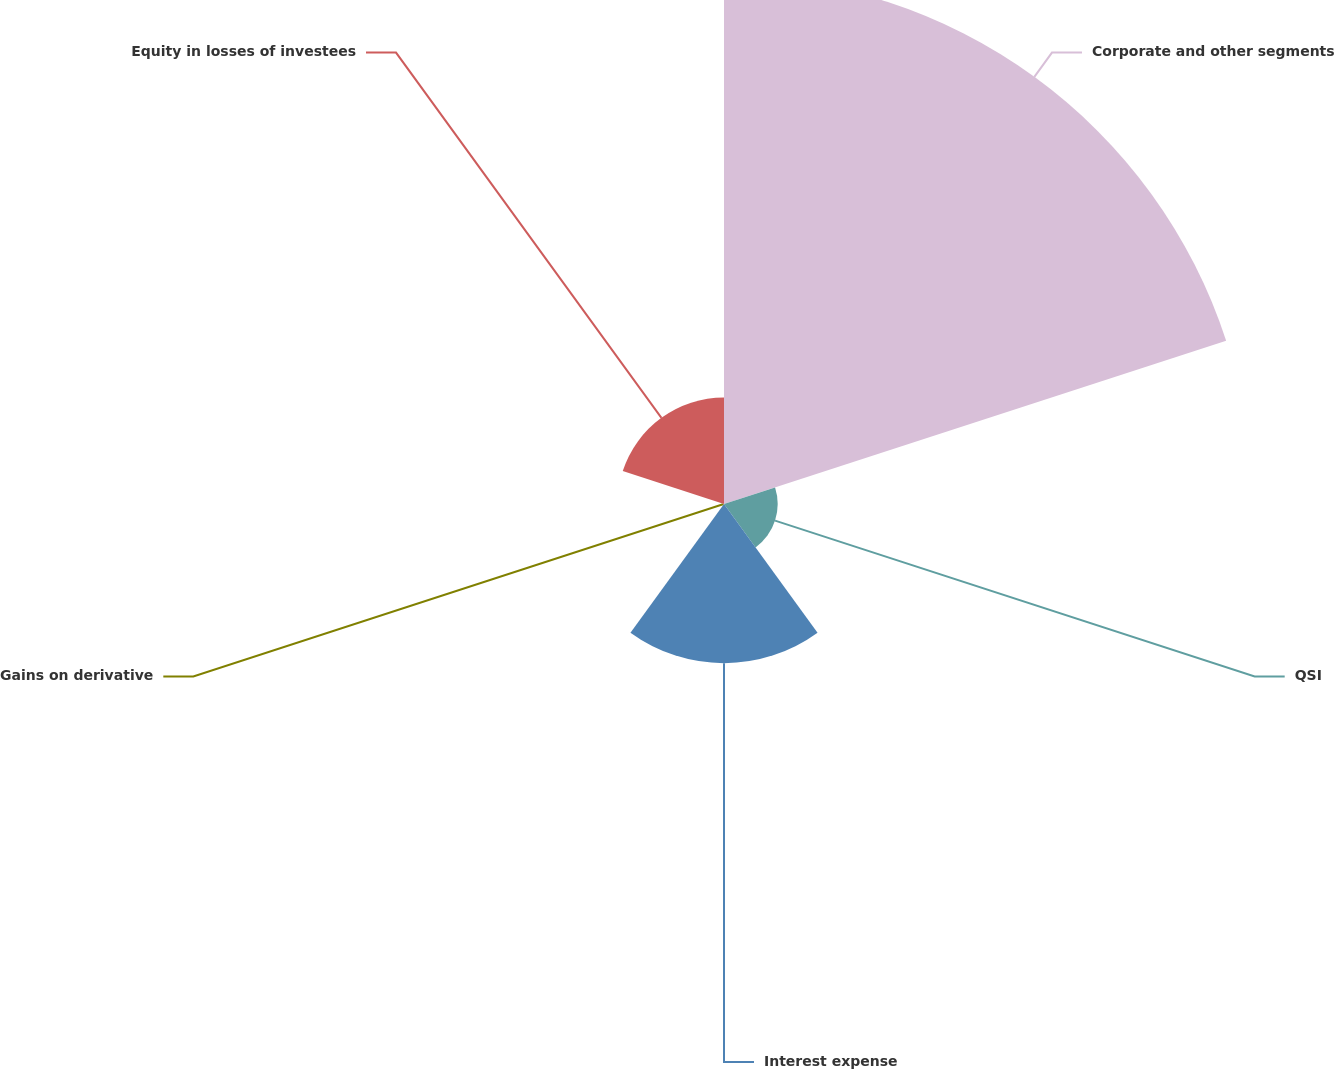Convert chart. <chart><loc_0><loc_0><loc_500><loc_500><pie_chart><fcel>Corporate and other segments<fcel>QSI<fcel>Interest expense<fcel>Gains on derivative<fcel>Equity in losses of investees<nl><fcel>62.24%<fcel>6.33%<fcel>18.76%<fcel>0.12%<fcel>12.55%<nl></chart> 